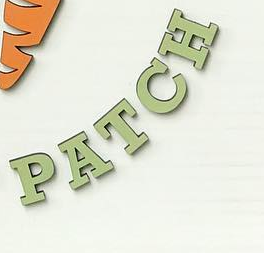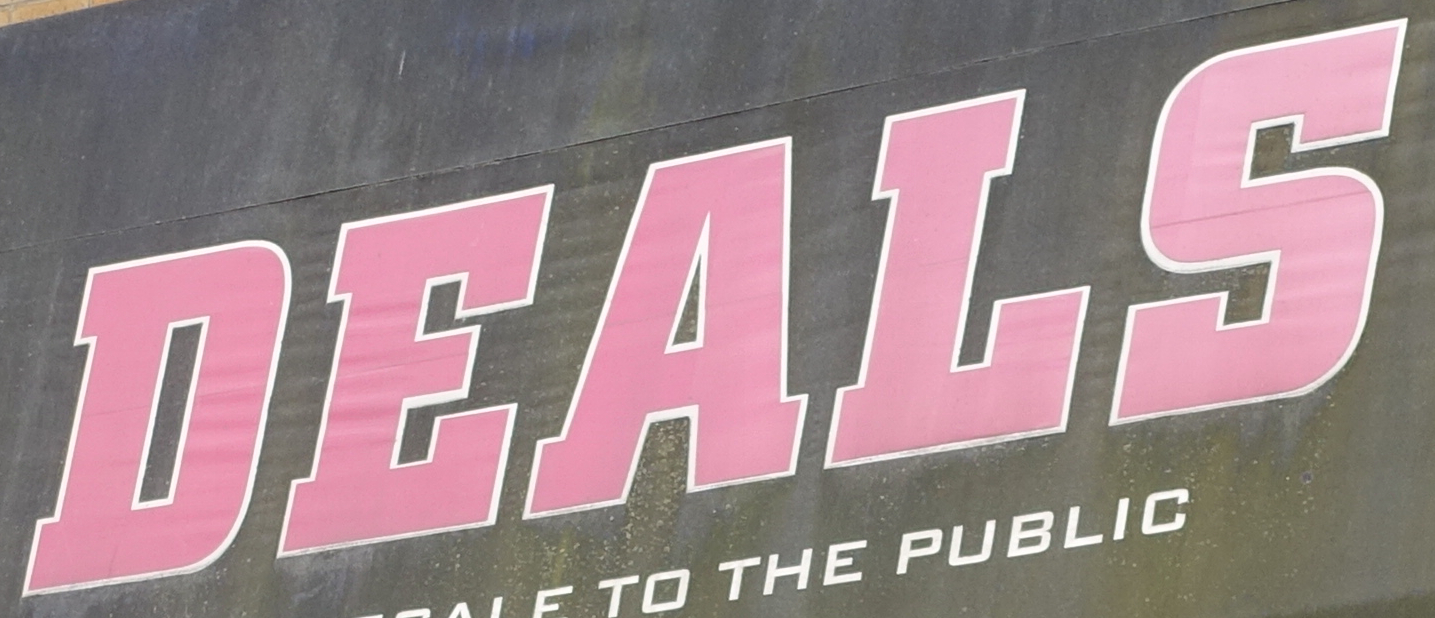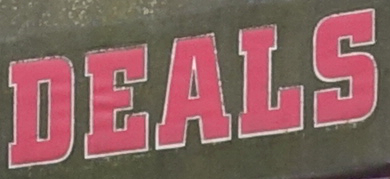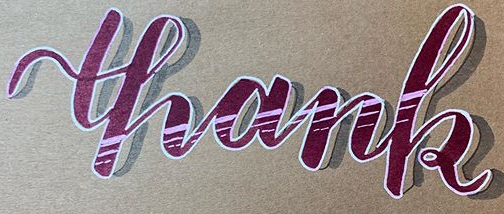Read the text content from these images in order, separated by a semicolon. PATCH; DEALS; DEALS; thank 